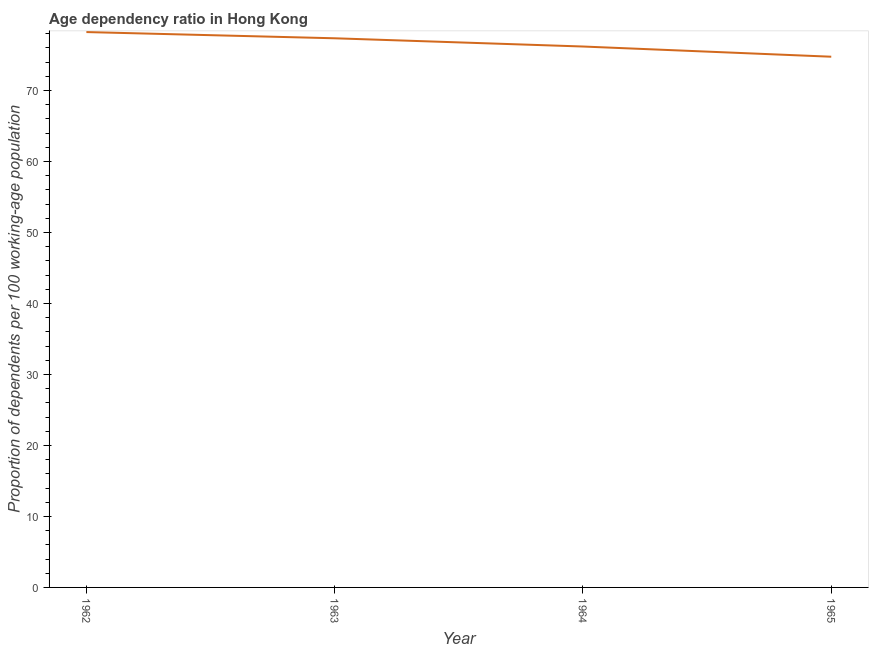What is the age dependency ratio in 1962?
Provide a short and direct response. 78.24. Across all years, what is the maximum age dependency ratio?
Offer a very short reply. 78.24. Across all years, what is the minimum age dependency ratio?
Make the answer very short. 74.77. In which year was the age dependency ratio maximum?
Your response must be concise. 1962. In which year was the age dependency ratio minimum?
Offer a terse response. 1965. What is the sum of the age dependency ratio?
Keep it short and to the point. 306.58. What is the difference between the age dependency ratio in 1964 and 1965?
Offer a terse response. 1.44. What is the average age dependency ratio per year?
Offer a terse response. 76.64. What is the median age dependency ratio?
Give a very brief answer. 76.78. In how many years, is the age dependency ratio greater than 20 ?
Provide a short and direct response. 4. What is the ratio of the age dependency ratio in 1963 to that in 1965?
Your answer should be very brief. 1.03. What is the difference between the highest and the second highest age dependency ratio?
Provide a short and direct response. 0.88. Is the sum of the age dependency ratio in 1962 and 1963 greater than the maximum age dependency ratio across all years?
Offer a terse response. Yes. What is the difference between the highest and the lowest age dependency ratio?
Provide a short and direct response. 3.47. In how many years, is the age dependency ratio greater than the average age dependency ratio taken over all years?
Give a very brief answer. 2. Does the age dependency ratio monotonically increase over the years?
Your response must be concise. No. What is the title of the graph?
Give a very brief answer. Age dependency ratio in Hong Kong. What is the label or title of the Y-axis?
Your response must be concise. Proportion of dependents per 100 working-age population. What is the Proportion of dependents per 100 working-age population in 1962?
Give a very brief answer. 78.24. What is the Proportion of dependents per 100 working-age population of 1963?
Make the answer very short. 77.36. What is the Proportion of dependents per 100 working-age population in 1964?
Provide a succinct answer. 76.2. What is the Proportion of dependents per 100 working-age population of 1965?
Your answer should be very brief. 74.77. What is the difference between the Proportion of dependents per 100 working-age population in 1962 and 1963?
Offer a very short reply. 0.88. What is the difference between the Proportion of dependents per 100 working-age population in 1962 and 1964?
Your answer should be very brief. 2.04. What is the difference between the Proportion of dependents per 100 working-age population in 1962 and 1965?
Offer a very short reply. 3.47. What is the difference between the Proportion of dependents per 100 working-age population in 1963 and 1964?
Offer a terse response. 1.16. What is the difference between the Proportion of dependents per 100 working-age population in 1963 and 1965?
Ensure brevity in your answer.  2.6. What is the difference between the Proportion of dependents per 100 working-age population in 1964 and 1965?
Provide a succinct answer. 1.44. What is the ratio of the Proportion of dependents per 100 working-age population in 1962 to that in 1963?
Your response must be concise. 1.01. What is the ratio of the Proportion of dependents per 100 working-age population in 1962 to that in 1965?
Offer a terse response. 1.05. What is the ratio of the Proportion of dependents per 100 working-age population in 1963 to that in 1964?
Your answer should be very brief. 1.01. What is the ratio of the Proportion of dependents per 100 working-age population in 1963 to that in 1965?
Offer a terse response. 1.03. What is the ratio of the Proportion of dependents per 100 working-age population in 1964 to that in 1965?
Offer a terse response. 1.02. 